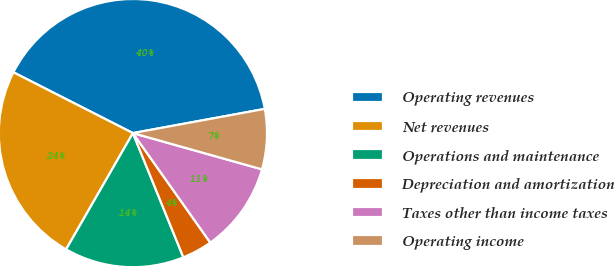Convert chart. <chart><loc_0><loc_0><loc_500><loc_500><pie_chart><fcel>Operating revenues<fcel>Net revenues<fcel>Operations and maintenance<fcel>Depreciation and amortization<fcel>Taxes other than income taxes<fcel>Operating income<nl><fcel>39.62%<fcel>24.19%<fcel>14.44%<fcel>3.65%<fcel>10.85%<fcel>7.25%<nl></chart> 